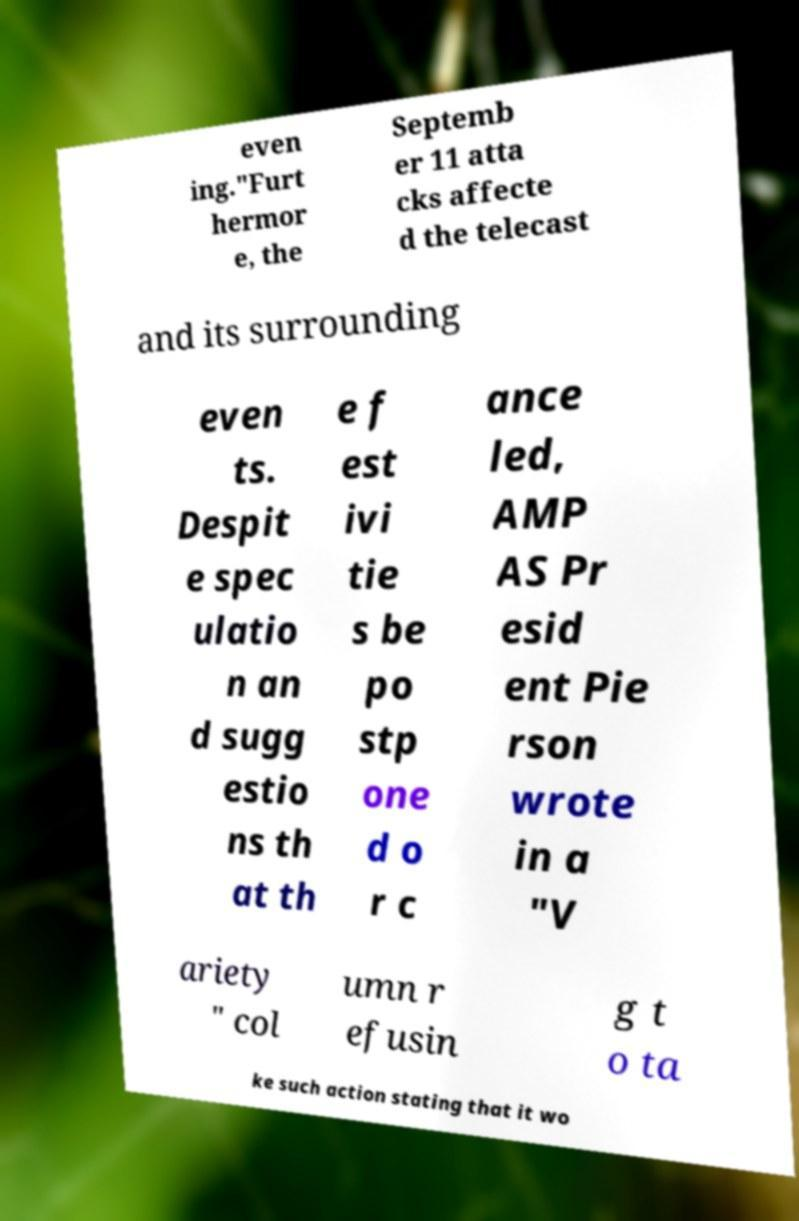Can you accurately transcribe the text from the provided image for me? even ing."Furt hermor e, the Septemb er 11 atta cks affecte d the telecast and its surrounding even ts. Despit e spec ulatio n an d sugg estio ns th at th e f est ivi tie s be po stp one d o r c ance led, AMP AS Pr esid ent Pie rson wrote in a "V ariety " col umn r efusin g t o ta ke such action stating that it wo 